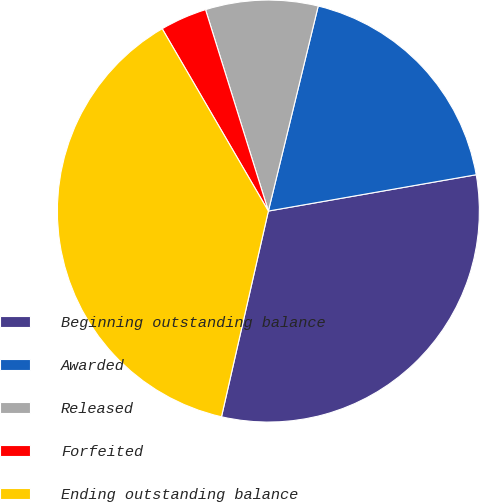Convert chart to OTSL. <chart><loc_0><loc_0><loc_500><loc_500><pie_chart><fcel>Beginning outstanding balance<fcel>Awarded<fcel>Released<fcel>Forfeited<fcel>Ending outstanding balance<nl><fcel>31.32%<fcel>18.45%<fcel>8.61%<fcel>3.58%<fcel>38.04%<nl></chart> 